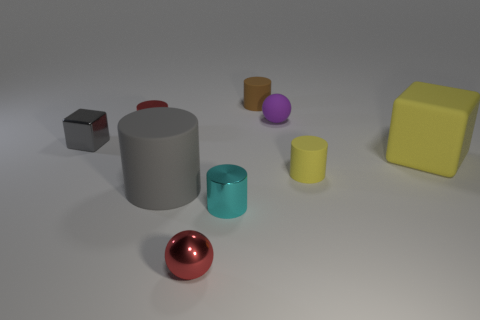Subtract 2 cylinders. How many cylinders are left? 3 Subtract all red cylinders. How many cylinders are left? 4 Subtract all tiny yellow cylinders. How many cylinders are left? 4 Subtract all green cylinders. Subtract all purple blocks. How many cylinders are left? 5 Subtract all spheres. How many objects are left? 7 Subtract 1 red spheres. How many objects are left? 8 Subtract all red metal spheres. Subtract all tiny shiny objects. How many objects are left? 4 Add 4 large yellow objects. How many large yellow objects are left? 5 Add 8 large purple rubber cylinders. How many large purple rubber cylinders exist? 8 